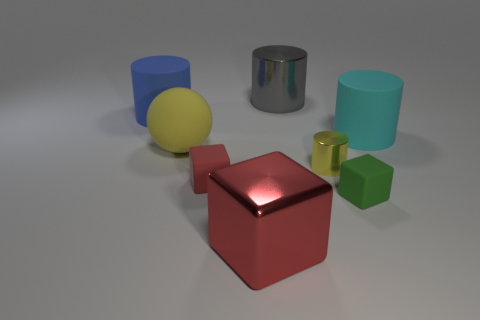What material is the sphere that is the same color as the tiny shiny cylinder?
Your response must be concise. Rubber. There is a big thing that is behind the thing left of the yellow object that is to the left of the small red matte thing; what is it made of?
Keep it short and to the point. Metal. What material is the cylinder in front of the big rubber cylinder that is in front of the blue matte thing made of?
Give a very brief answer. Metal. Is the number of big objects in front of the large shiny cube less than the number of tiny red rubber blocks?
Provide a short and direct response. Yes. What is the shape of the shiny object in front of the red rubber cube?
Give a very brief answer. Cube. There is a gray cylinder; is it the same size as the rubber cylinder on the right side of the blue cylinder?
Your answer should be very brief. Yes. Is there a large cube that has the same material as the tiny red block?
Give a very brief answer. No. What number of balls are green rubber things or large red metal things?
Your answer should be compact. 0. There is a red thing that is behind the green object; are there any large blue rubber things on the right side of it?
Offer a very short reply. No. Is the number of big matte things less than the number of large blue rubber objects?
Your response must be concise. No. 